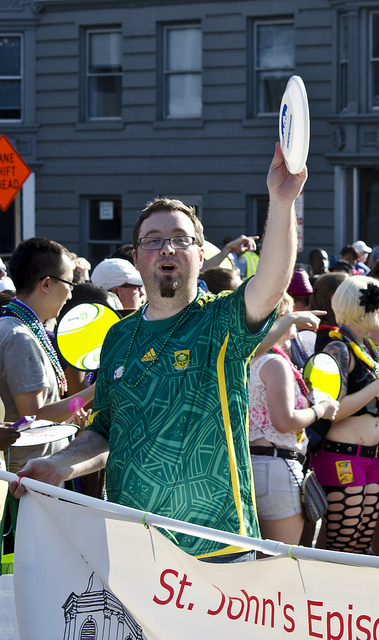<image>Did he just win a game? It is unclear if he just won a game. It might be a no, but also can be yes. Did he just win a game? I don't know if he just won a game. It could be either yes or no. 